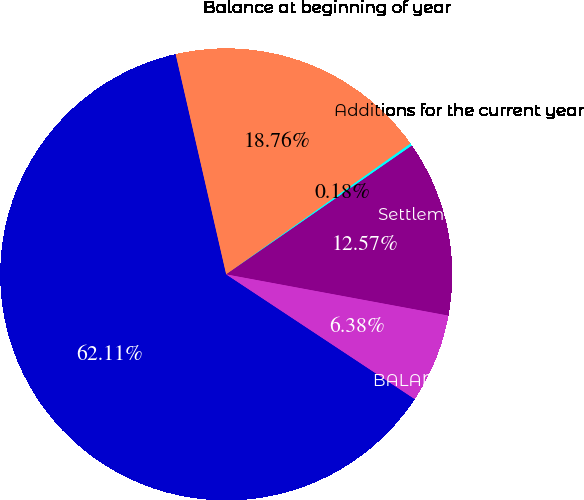Convert chart. <chart><loc_0><loc_0><loc_500><loc_500><pie_chart><fcel>(in Millions)<fcel>Balance at beginning of year<fcel>Additions for the current year<fcel>Settlements during the period<fcel>BALANCE AT END OF YEAR<nl><fcel>62.11%<fcel>18.76%<fcel>0.18%<fcel>12.57%<fcel>6.38%<nl></chart> 